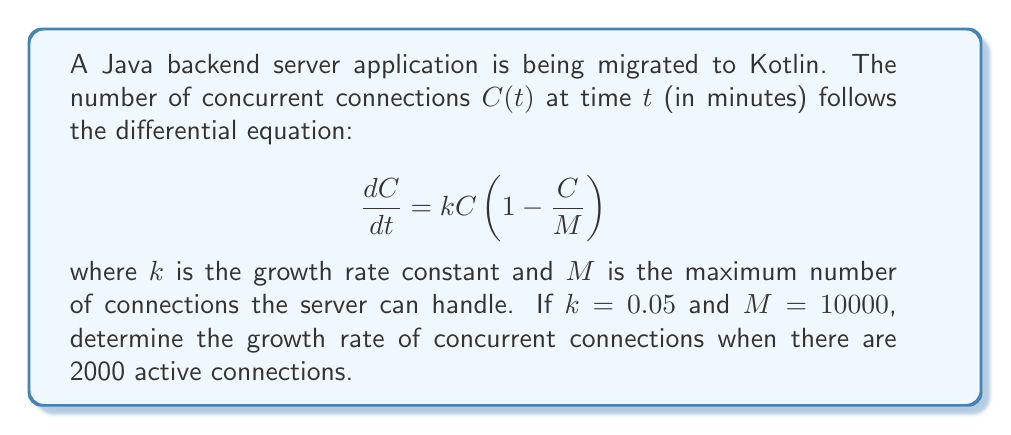Provide a solution to this math problem. To solve this problem, we need to use the given differential equation and substitute the known values. Let's break it down step-by-step:

1. The differential equation is given as:
   $$\frac{dC}{dt} = kC(1 - \frac{C}{M})$$

2. We are given the following values:
   $k = 0.05$ (growth rate constant)
   $M = 10000$ (maximum number of connections)
   $C = 2000$ (current number of active connections)

3. To find the growth rate, we need to calculate $\frac{dC}{dt}$ at $C = 2000$. Let's substitute the values into the equation:

   $$\frac{dC}{dt} = 0.05 \cdot 2000 \cdot (1 - \frac{2000}{10000})$$

4. Simplify the expression inside the parentheses:
   $$\frac{dC}{dt} = 0.05 \cdot 2000 \cdot (1 - 0.2)$$
   $$\frac{dC}{dt} = 0.05 \cdot 2000 \cdot 0.8$$

5. Calculate the final result:
   $$\frac{dC}{dt} = 0.05 \cdot 2000 \cdot 0.8 = 80$$

Therefore, when there are 2000 active connections, the growth rate of concurrent connections is 80 connections per minute.
Answer: The growth rate of concurrent connections when there are 2000 active connections is 80 connections per minute. 